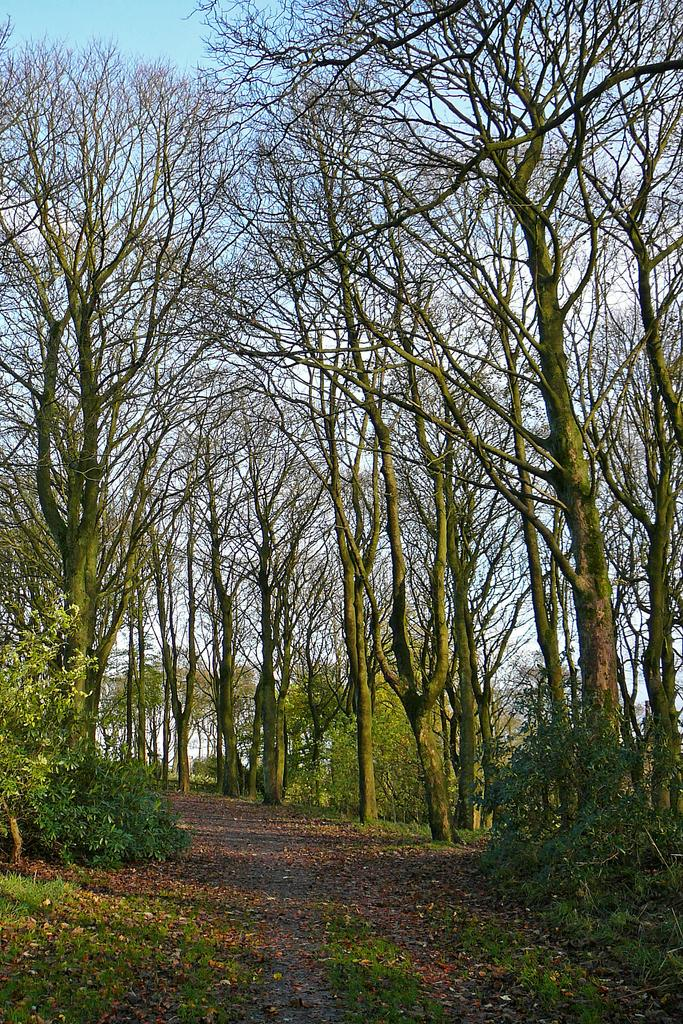What is covering the ground at the bottom of the image? There are dry leaves and grass on the ground at the bottom of the image. What type of vegetation can be seen in the foreground of the image? There are small plants in the background of the image. What other natural elements are visible in the background of the image? There are trees in the background of the image. What can be seen beyond the trees in the background of the image? The sky is visible behind the trees in the background of the image. What color bead is hanging from the tree in the image? There is no bead hanging from the tree in the image. Is there a basketball court visible in the image? There is no basketball court present in the image. 